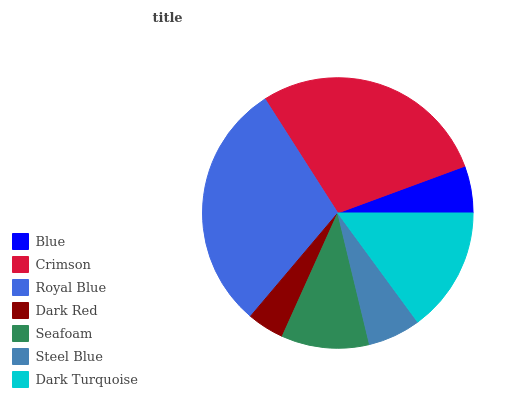Is Dark Red the minimum?
Answer yes or no. Yes. Is Royal Blue the maximum?
Answer yes or no. Yes. Is Crimson the minimum?
Answer yes or no. No. Is Crimson the maximum?
Answer yes or no. No. Is Crimson greater than Blue?
Answer yes or no. Yes. Is Blue less than Crimson?
Answer yes or no. Yes. Is Blue greater than Crimson?
Answer yes or no. No. Is Crimson less than Blue?
Answer yes or no. No. Is Seafoam the high median?
Answer yes or no. Yes. Is Seafoam the low median?
Answer yes or no. Yes. Is Blue the high median?
Answer yes or no. No. Is Blue the low median?
Answer yes or no. No. 